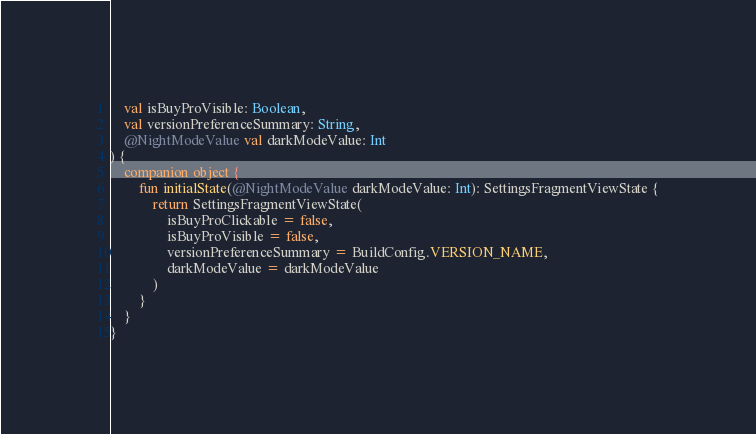Convert code to text. <code><loc_0><loc_0><loc_500><loc_500><_Kotlin_>    val isBuyProVisible: Boolean,
    val versionPreferenceSummary: String,
    @NightModeValue val darkModeValue: Int
) {
    companion object {
        fun initialState(@NightModeValue darkModeValue: Int): SettingsFragmentViewState {
            return SettingsFragmentViewState(
                isBuyProClickable = false,
                isBuyProVisible = false,
                versionPreferenceSummary = BuildConfig.VERSION_NAME,
                darkModeValue = darkModeValue
            )
        }
    }
}
</code> 